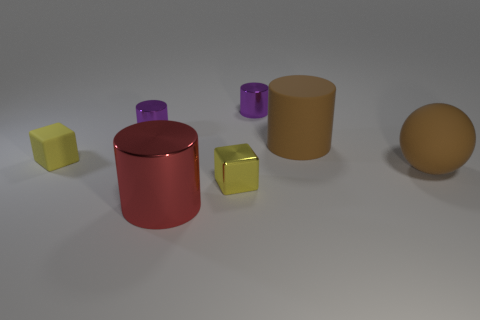Add 2 big brown rubber objects. How many objects exist? 9 Subtract all cylinders. How many objects are left? 3 Subtract all big cylinders. Subtract all big red shiny objects. How many objects are left? 4 Add 7 brown rubber balls. How many brown rubber balls are left? 8 Add 6 tiny yellow blocks. How many tiny yellow blocks exist? 8 Subtract 0 yellow spheres. How many objects are left? 7 